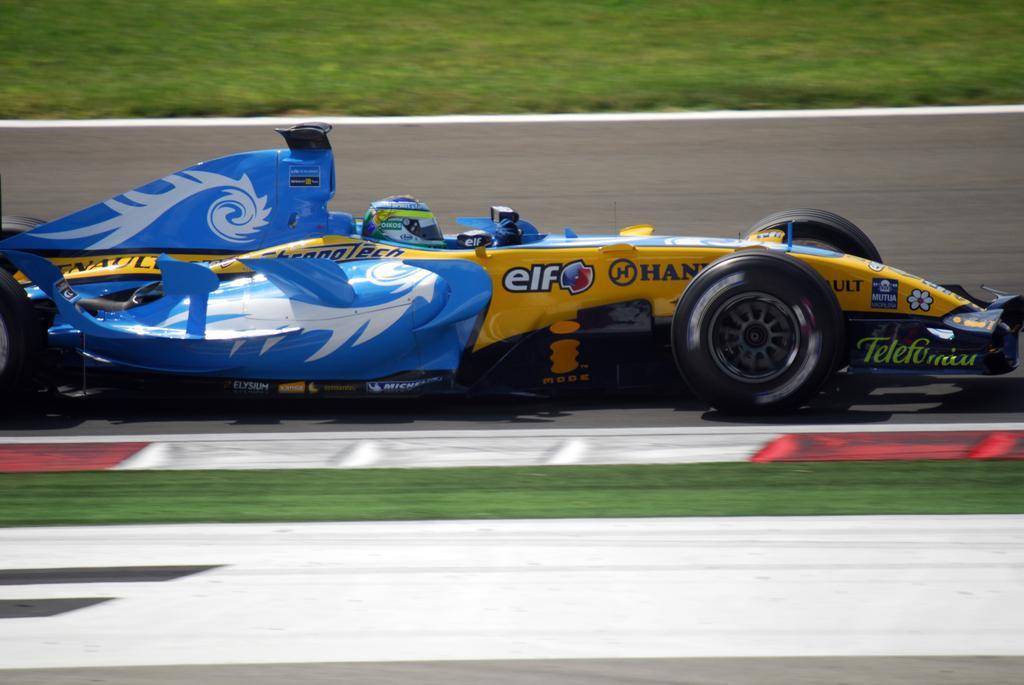Describe this image in one or two sentences. The image is taken in a formula one race. In the foreground there is grass and road. In the center of the picture there is a go kart moving on the road. At the top it is grass. 